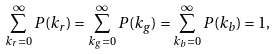<formula> <loc_0><loc_0><loc_500><loc_500>\sum _ { k _ { r } = 0 } ^ { \infty } P ( k _ { r } ) = \sum _ { k _ { g } = 0 } ^ { \infty } P ( k _ { g } ) = \sum _ { k _ { b } = 0 } ^ { \infty } P ( k _ { b } ) = 1 ,</formula> 